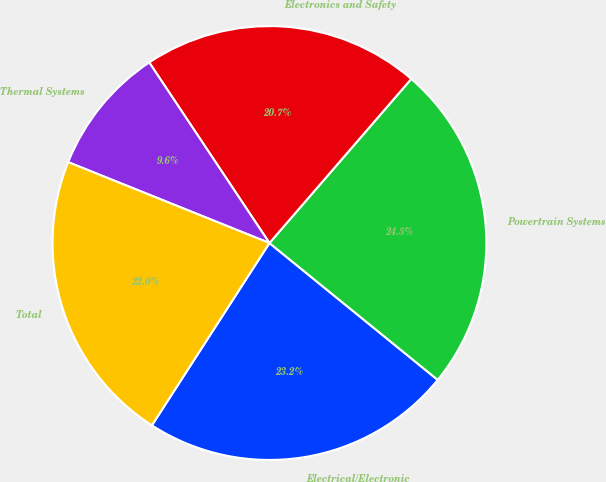Convert chart. <chart><loc_0><loc_0><loc_500><loc_500><pie_chart><fcel>Electrical/Electronic<fcel>Powertrain Systems<fcel>Electronics and Safety<fcel>Thermal Systems<fcel>Total<nl><fcel>23.25%<fcel>24.53%<fcel>20.69%<fcel>9.57%<fcel>21.97%<nl></chart> 